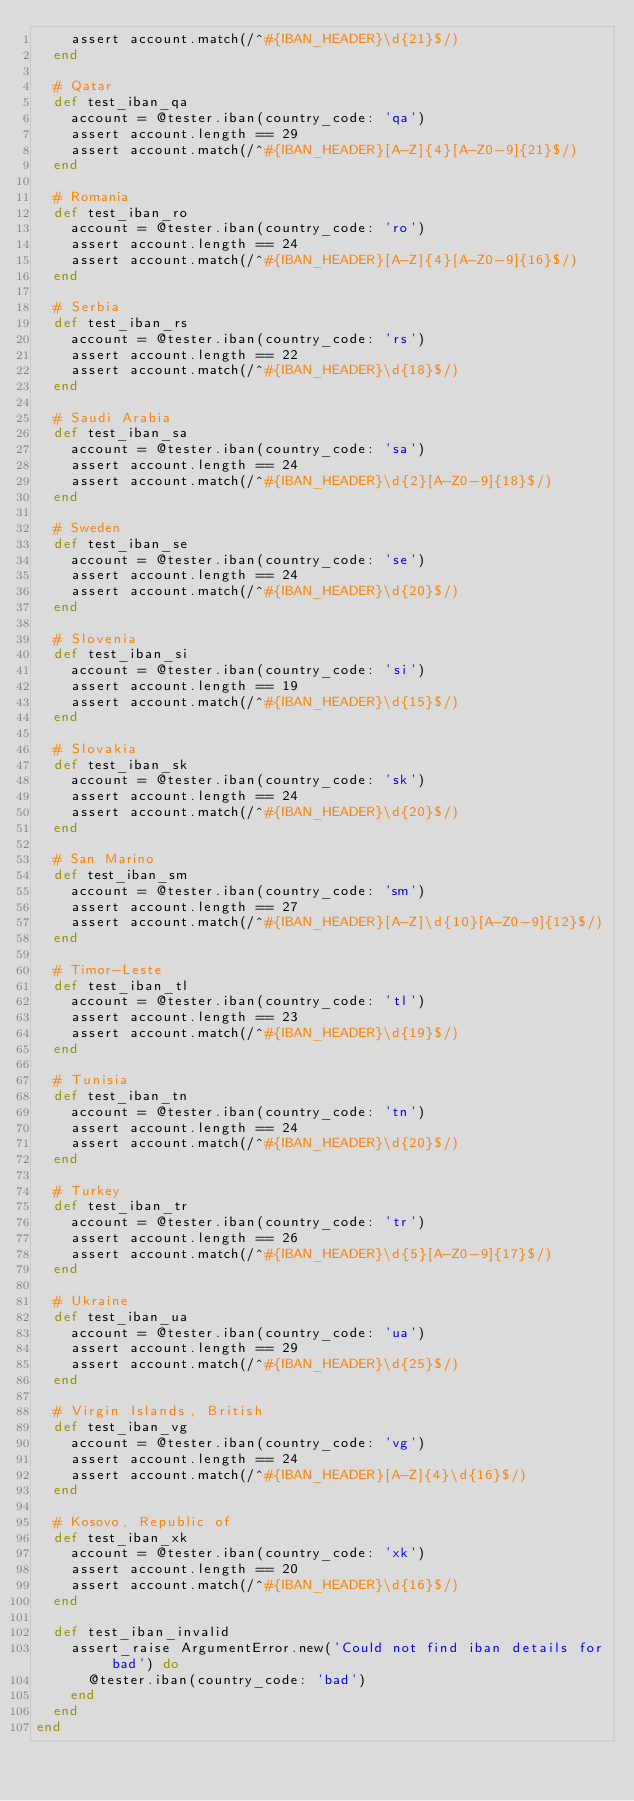Convert code to text. <code><loc_0><loc_0><loc_500><loc_500><_Ruby_>    assert account.match(/^#{IBAN_HEADER}\d{21}$/)
  end

  # Qatar
  def test_iban_qa
    account = @tester.iban(country_code: 'qa')
    assert account.length == 29
    assert account.match(/^#{IBAN_HEADER}[A-Z]{4}[A-Z0-9]{21}$/)
  end

  # Romania
  def test_iban_ro
    account = @tester.iban(country_code: 'ro')
    assert account.length == 24
    assert account.match(/^#{IBAN_HEADER}[A-Z]{4}[A-Z0-9]{16}$/)
  end

  # Serbia
  def test_iban_rs
    account = @tester.iban(country_code: 'rs')
    assert account.length == 22
    assert account.match(/^#{IBAN_HEADER}\d{18}$/)
  end

  # Saudi Arabia
  def test_iban_sa
    account = @tester.iban(country_code: 'sa')
    assert account.length == 24
    assert account.match(/^#{IBAN_HEADER}\d{2}[A-Z0-9]{18}$/)
  end

  # Sweden
  def test_iban_se
    account = @tester.iban(country_code: 'se')
    assert account.length == 24
    assert account.match(/^#{IBAN_HEADER}\d{20}$/)
  end

  # Slovenia
  def test_iban_si
    account = @tester.iban(country_code: 'si')
    assert account.length == 19
    assert account.match(/^#{IBAN_HEADER}\d{15}$/)
  end

  # Slovakia
  def test_iban_sk
    account = @tester.iban(country_code: 'sk')
    assert account.length == 24
    assert account.match(/^#{IBAN_HEADER}\d{20}$/)
  end

  # San Marino
  def test_iban_sm
    account = @tester.iban(country_code: 'sm')
    assert account.length == 27
    assert account.match(/^#{IBAN_HEADER}[A-Z]\d{10}[A-Z0-9]{12}$/)
  end

  # Timor-Leste
  def test_iban_tl
    account = @tester.iban(country_code: 'tl')
    assert account.length == 23
    assert account.match(/^#{IBAN_HEADER}\d{19}$/)
  end

  # Tunisia
  def test_iban_tn
    account = @tester.iban(country_code: 'tn')
    assert account.length == 24
    assert account.match(/^#{IBAN_HEADER}\d{20}$/)
  end

  # Turkey
  def test_iban_tr
    account = @tester.iban(country_code: 'tr')
    assert account.length == 26
    assert account.match(/^#{IBAN_HEADER}\d{5}[A-Z0-9]{17}$/)
  end

  # Ukraine
  def test_iban_ua
    account = @tester.iban(country_code: 'ua')
    assert account.length == 29
    assert account.match(/^#{IBAN_HEADER}\d{25}$/)
  end

  # Virgin Islands, British
  def test_iban_vg
    account = @tester.iban(country_code: 'vg')
    assert account.length == 24
    assert account.match(/^#{IBAN_HEADER}[A-Z]{4}\d{16}$/)
  end

  # Kosovo, Republic of
  def test_iban_xk
    account = @tester.iban(country_code: 'xk')
    assert account.length == 20
    assert account.match(/^#{IBAN_HEADER}\d{16}$/)
  end

  def test_iban_invalid
    assert_raise ArgumentError.new('Could not find iban details for bad') do
      @tester.iban(country_code: 'bad')
    end
  end
end
</code> 